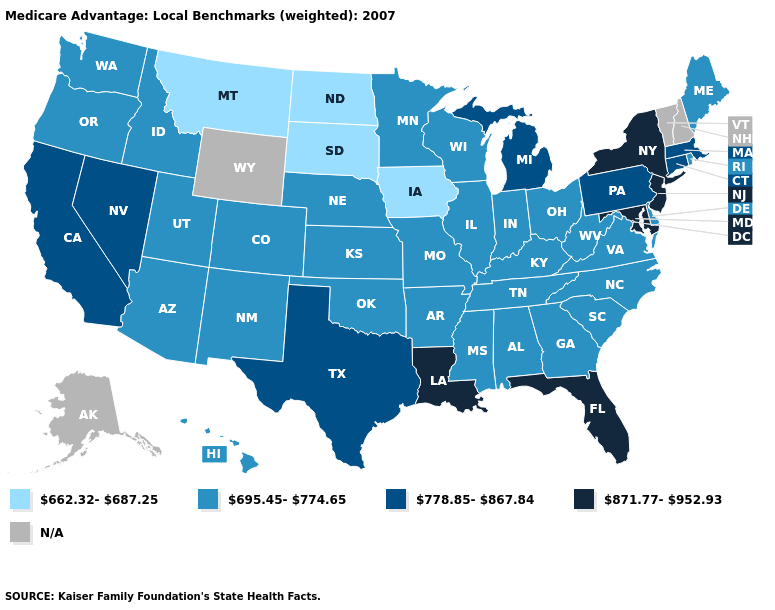Among the states that border Mississippi , which have the lowest value?
Short answer required. Alabama, Arkansas, Tennessee. What is the highest value in the USA?
Short answer required. 871.77-952.93. What is the value of Kansas?
Write a very short answer. 695.45-774.65. Does the first symbol in the legend represent the smallest category?
Concise answer only. Yes. Name the states that have a value in the range N/A?
Be succinct. Alaska, New Hampshire, Vermont, Wyoming. Name the states that have a value in the range N/A?
Short answer required. Alaska, New Hampshire, Vermont, Wyoming. Name the states that have a value in the range 695.45-774.65?
Concise answer only. Alabama, Arkansas, Arizona, Colorado, Delaware, Georgia, Hawaii, Idaho, Illinois, Indiana, Kansas, Kentucky, Maine, Minnesota, Missouri, Mississippi, North Carolina, Nebraska, New Mexico, Ohio, Oklahoma, Oregon, Rhode Island, South Carolina, Tennessee, Utah, Virginia, Washington, Wisconsin, West Virginia. What is the value of California?
Quick response, please. 778.85-867.84. Name the states that have a value in the range N/A?
Short answer required. Alaska, New Hampshire, Vermont, Wyoming. Which states have the lowest value in the West?
Keep it brief. Montana. Name the states that have a value in the range 778.85-867.84?
Keep it brief. California, Connecticut, Massachusetts, Michigan, Nevada, Pennsylvania, Texas. Does Illinois have the lowest value in the MidWest?
Concise answer only. No. Does the map have missing data?
Write a very short answer. Yes. 